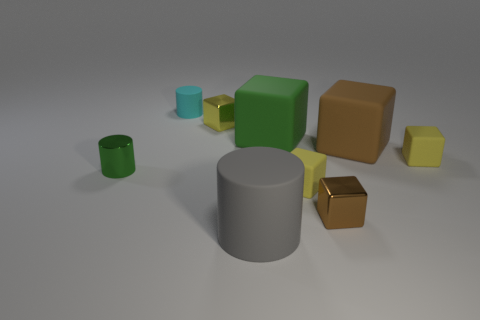The tiny cylinder that is made of the same material as the big gray cylinder is what color?
Give a very brief answer. Cyan. There is a large brown thing; is its shape the same as the object on the left side of the cyan cylinder?
Ensure brevity in your answer.  No. There is a big cylinder; are there any brown shiny blocks behind it?
Provide a succinct answer. Yes. What is the material of the block that is the same color as the tiny shiny cylinder?
Offer a terse response. Rubber. There is a brown matte thing; is it the same size as the metal cylinder behind the tiny brown shiny block?
Keep it short and to the point. No. Are there any big objects that have the same color as the metal cylinder?
Offer a very short reply. Yes. Is there another small rubber object that has the same shape as the small brown object?
Your response must be concise. Yes. The small object that is right of the small cyan rubber cylinder and to the left of the big cylinder has what shape?
Offer a terse response. Cube. How many tiny cyan cylinders are the same material as the large brown object?
Your response must be concise. 1. Is the number of tiny matte cylinders that are behind the cyan thing less than the number of gray matte balls?
Keep it short and to the point. No. 